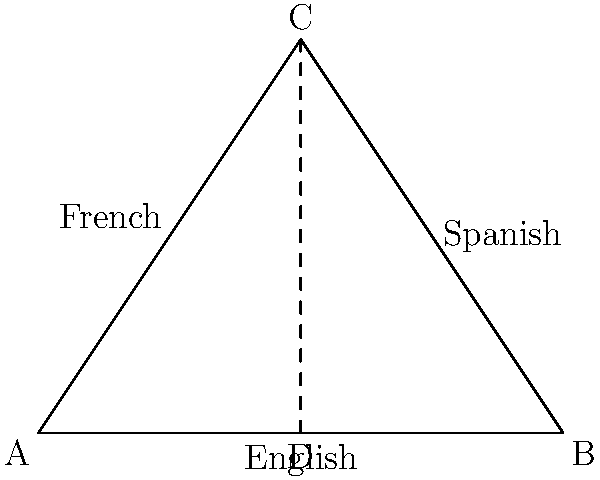In a language proficiency assessment, triangle ABC represents your multilingual abilities. The sides of the triangle correspond to your proficiency in English (AB), Spanish (BC), and French (AC). If AD is the height of the triangle and CD bisects angle ACB, what can be concluded about your language skills based on the properties of congruent triangles? Let's approach this step-by-step:

1) Given that CD bisects angle ACB, we know that angle ACD = angle BCD.

2) AD is the height of the triangle, which means it's perpendicular to AB. This creates two right angles: angle ADA = angle BDA = 90°.

3) We now have two triangles: ACD and BCD. Let's compare them:
   - They share a common side: CD
   - They have equal angles at C (given by the bisector)
   - They both have a right angle (at D)

4) By the AAS (Angle-Angle-Side) congruence criterion, triangles ACD and BCD are congruent.

5) In congruent triangles, corresponding sides are equal. This means that AC = BC.

6) Relating this back to language proficiency:
   - AC represents French proficiency
   - BC represents Spanish proficiency

7) The congruence of these sides indicates that your proficiency in French and Spanish is equal.

8) Note that we can't conclude anything about English proficiency (represented by AB) in relation to the other languages based solely on this information.
Answer: Equal proficiency in French and Spanish 